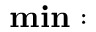<formula> <loc_0><loc_0><loc_500><loc_500>\min \colon</formula> 